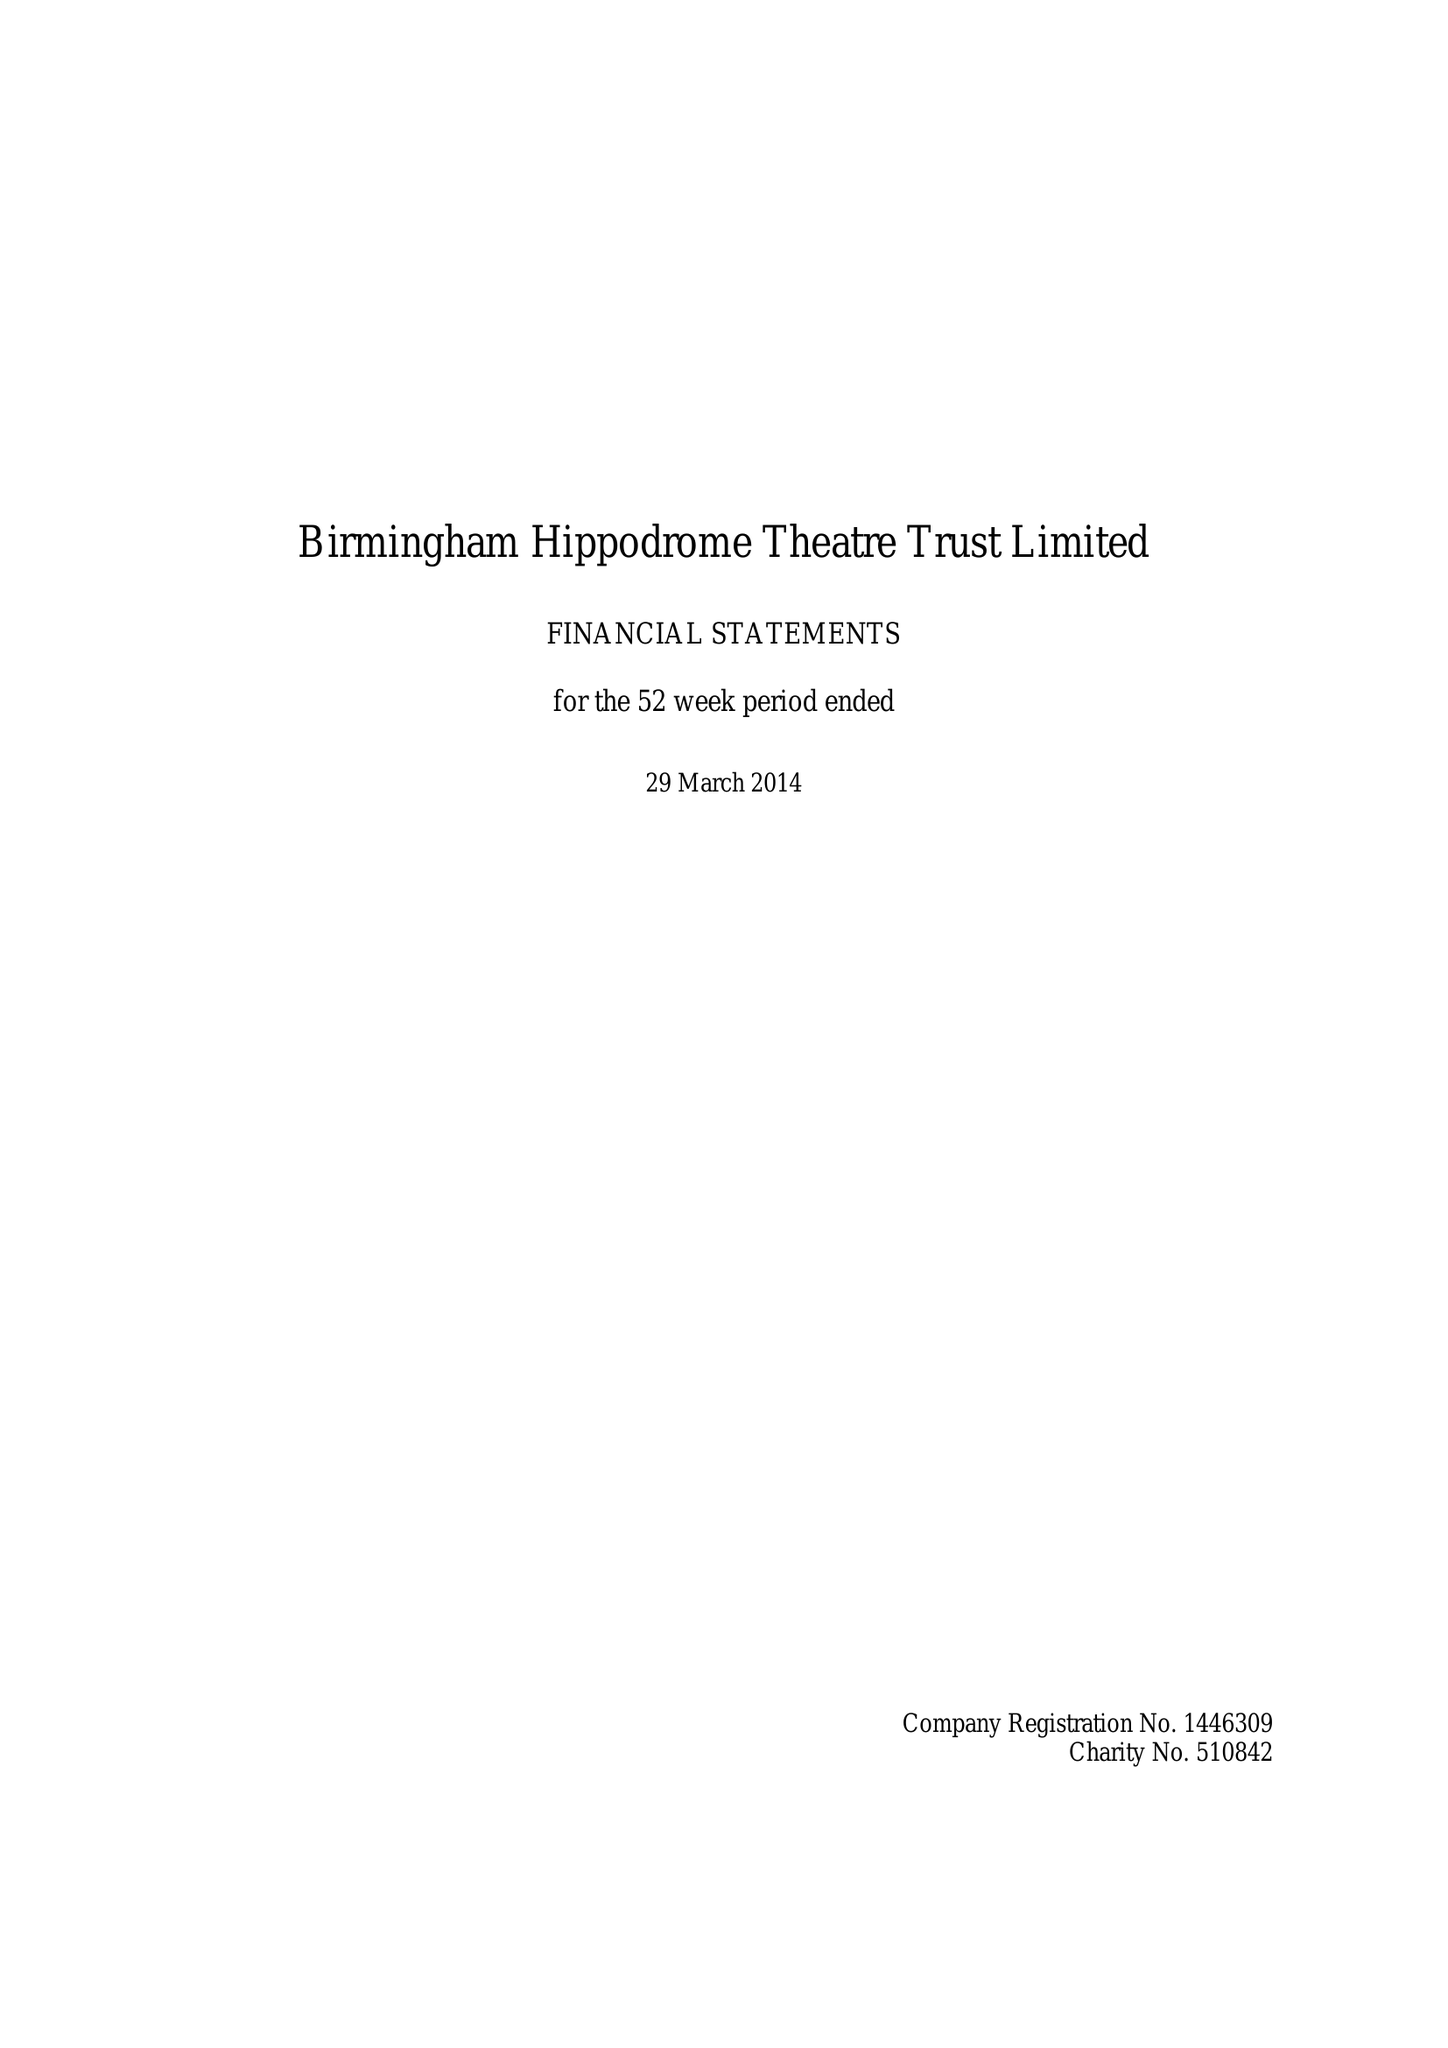What is the value for the address__street_line?
Answer the question using a single word or phrase. HURST STREET 